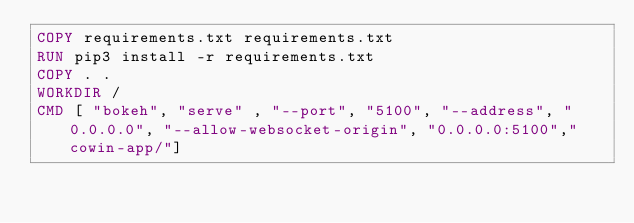<code> <loc_0><loc_0><loc_500><loc_500><_Dockerfile_>COPY requirements.txt requirements.txt
RUN pip3 install -r requirements.txt
COPY . .
WORKDIR /
CMD [ "bokeh", "serve" , "--port", "5100", "--address", "0.0.0.0", "--allow-websocket-origin", "0.0.0.0:5100","cowin-app/"]
</code> 